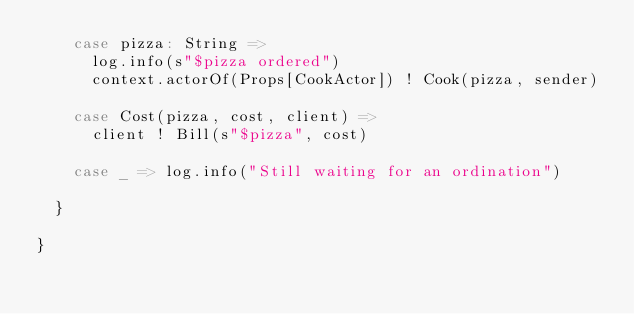<code> <loc_0><loc_0><loc_500><loc_500><_Scala_>    case pizza: String =>
      log.info(s"$pizza ordered")
      context.actorOf(Props[CookActor]) ! Cook(pizza, sender)

    case Cost(pizza, cost, client) =>
      client ! Bill(s"$pizza", cost)

    case _ => log.info("Still waiting for an ordination")

  }

}
</code> 